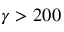<formula> <loc_0><loc_0><loc_500><loc_500>\gamma > 2 0 0</formula> 